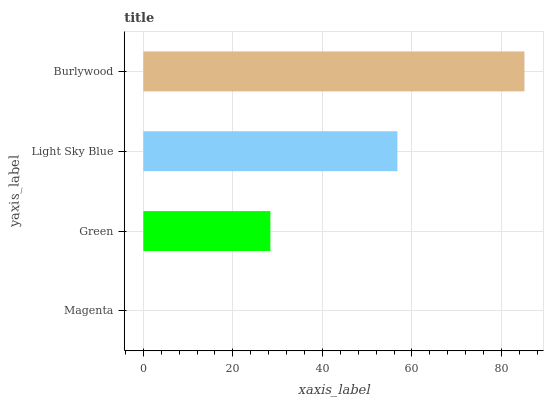Is Magenta the minimum?
Answer yes or no. Yes. Is Burlywood the maximum?
Answer yes or no. Yes. Is Green the minimum?
Answer yes or no. No. Is Green the maximum?
Answer yes or no. No. Is Green greater than Magenta?
Answer yes or no. Yes. Is Magenta less than Green?
Answer yes or no. Yes. Is Magenta greater than Green?
Answer yes or no. No. Is Green less than Magenta?
Answer yes or no. No. Is Light Sky Blue the high median?
Answer yes or no. Yes. Is Green the low median?
Answer yes or no. Yes. Is Magenta the high median?
Answer yes or no. No. Is Light Sky Blue the low median?
Answer yes or no. No. 